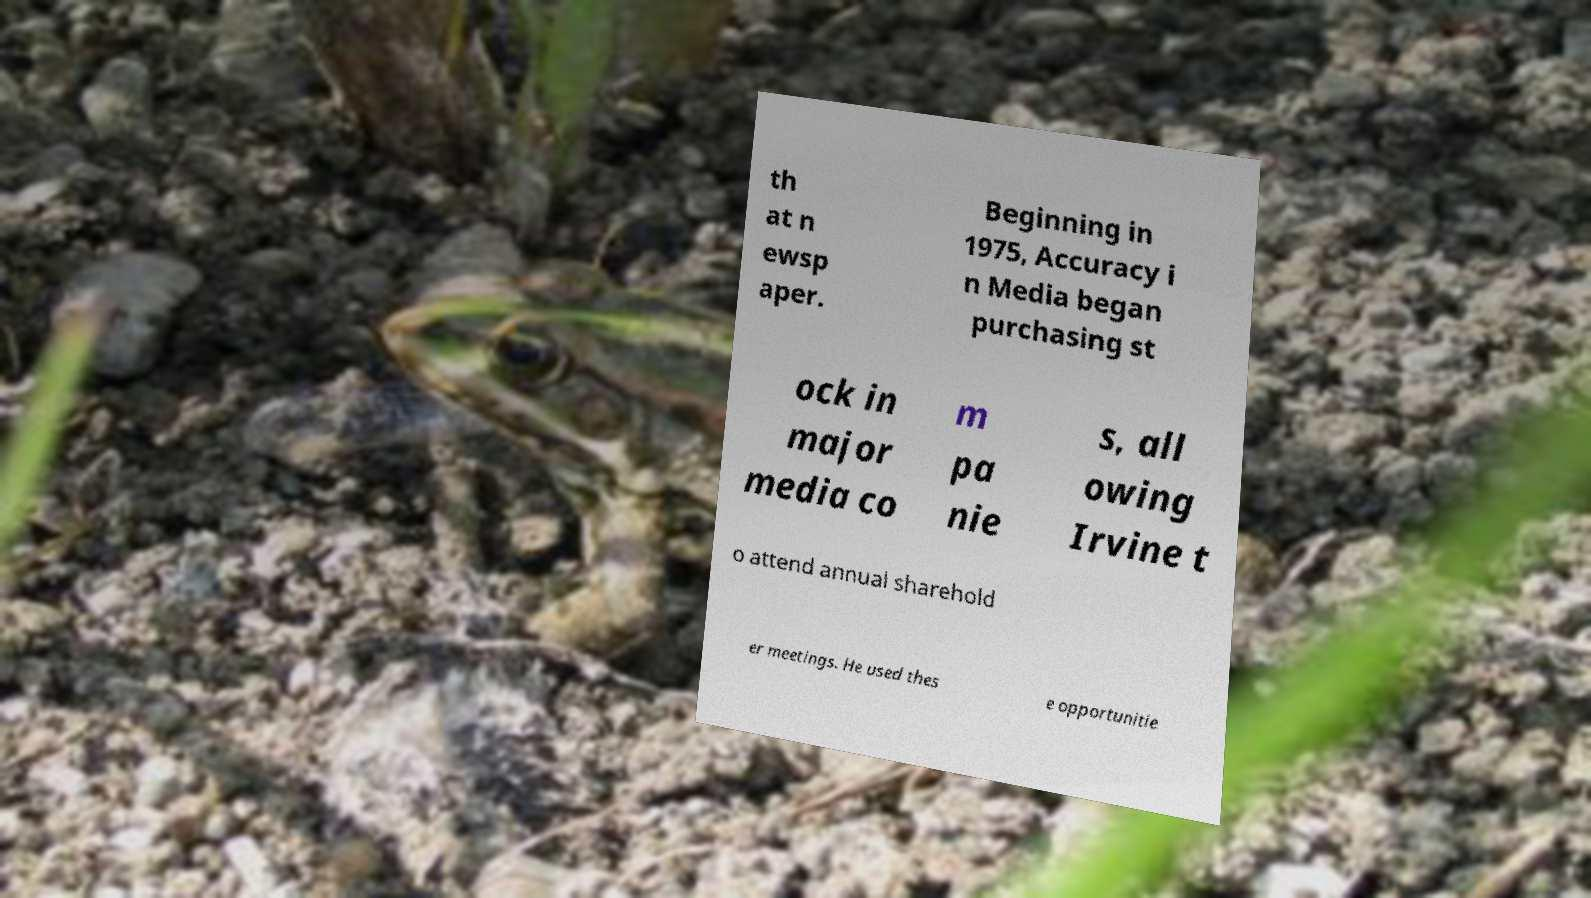What messages or text are displayed in this image? I need them in a readable, typed format. th at n ewsp aper. Beginning in 1975, Accuracy i n Media began purchasing st ock in major media co m pa nie s, all owing Irvine t o attend annual sharehold er meetings. He used thes e opportunitie 